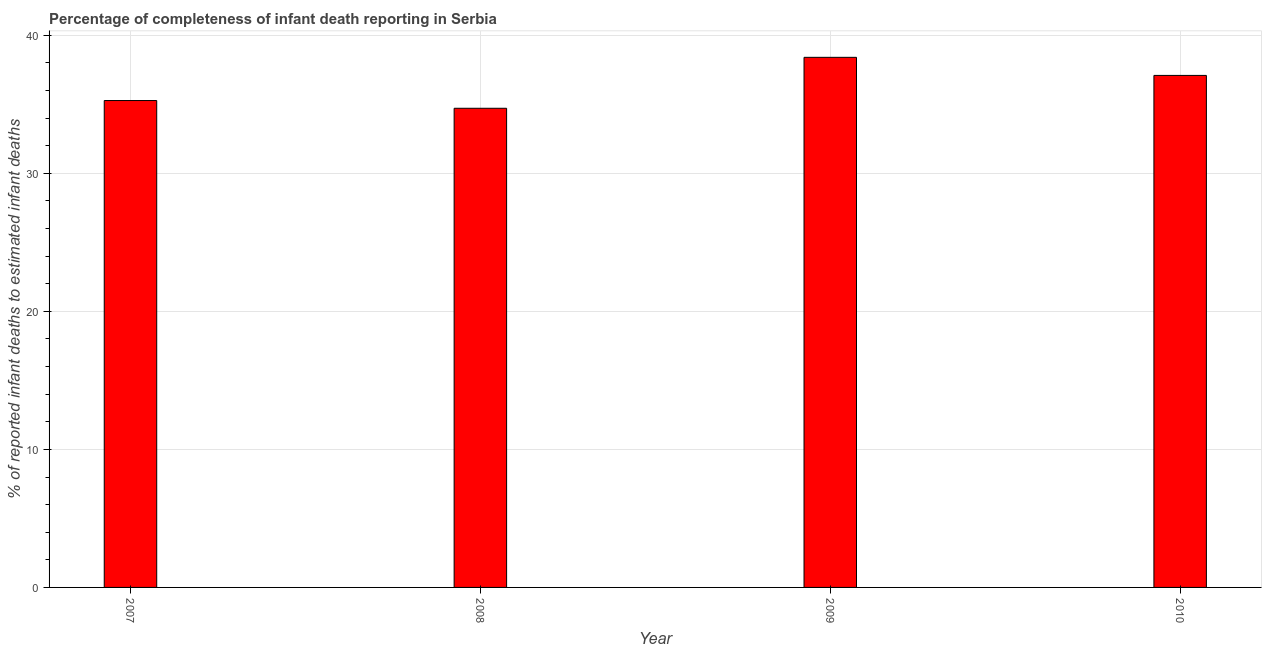Does the graph contain any zero values?
Keep it short and to the point. No. Does the graph contain grids?
Provide a short and direct response. Yes. What is the title of the graph?
Give a very brief answer. Percentage of completeness of infant death reporting in Serbia. What is the label or title of the X-axis?
Your response must be concise. Year. What is the label or title of the Y-axis?
Make the answer very short. % of reported infant deaths to estimated infant deaths. What is the completeness of infant death reporting in 2007?
Provide a succinct answer. 35.28. Across all years, what is the maximum completeness of infant death reporting?
Your answer should be very brief. 38.41. Across all years, what is the minimum completeness of infant death reporting?
Give a very brief answer. 34.72. In which year was the completeness of infant death reporting maximum?
Give a very brief answer. 2009. In which year was the completeness of infant death reporting minimum?
Your answer should be very brief. 2008. What is the sum of the completeness of infant death reporting?
Your answer should be very brief. 145.5. What is the difference between the completeness of infant death reporting in 2007 and 2009?
Provide a short and direct response. -3.13. What is the average completeness of infant death reporting per year?
Give a very brief answer. 36.38. What is the median completeness of infant death reporting?
Provide a succinct answer. 36.19. Do a majority of the years between 2008 and 2007 (inclusive) have completeness of infant death reporting greater than 2 %?
Provide a succinct answer. No. What is the ratio of the completeness of infant death reporting in 2007 to that in 2009?
Make the answer very short. 0.92. Is the completeness of infant death reporting in 2008 less than that in 2009?
Keep it short and to the point. Yes. Is the difference between the completeness of infant death reporting in 2009 and 2010 greater than the difference between any two years?
Ensure brevity in your answer.  No. What is the difference between the highest and the second highest completeness of infant death reporting?
Give a very brief answer. 1.31. Is the sum of the completeness of infant death reporting in 2007 and 2009 greater than the maximum completeness of infant death reporting across all years?
Your response must be concise. Yes. What is the difference between the highest and the lowest completeness of infant death reporting?
Make the answer very short. 3.69. In how many years, is the completeness of infant death reporting greater than the average completeness of infant death reporting taken over all years?
Your response must be concise. 2. How many bars are there?
Keep it short and to the point. 4. Are all the bars in the graph horizontal?
Ensure brevity in your answer.  No. What is the % of reported infant deaths to estimated infant deaths in 2007?
Your response must be concise. 35.28. What is the % of reported infant deaths to estimated infant deaths in 2008?
Provide a succinct answer. 34.72. What is the % of reported infant deaths to estimated infant deaths in 2009?
Ensure brevity in your answer.  38.41. What is the % of reported infant deaths to estimated infant deaths in 2010?
Offer a very short reply. 37.1. What is the difference between the % of reported infant deaths to estimated infant deaths in 2007 and 2008?
Provide a succinct answer. 0.56. What is the difference between the % of reported infant deaths to estimated infant deaths in 2007 and 2009?
Provide a short and direct response. -3.13. What is the difference between the % of reported infant deaths to estimated infant deaths in 2007 and 2010?
Keep it short and to the point. -1.82. What is the difference between the % of reported infant deaths to estimated infant deaths in 2008 and 2009?
Your answer should be compact. -3.69. What is the difference between the % of reported infant deaths to estimated infant deaths in 2008 and 2010?
Your response must be concise. -2.38. What is the difference between the % of reported infant deaths to estimated infant deaths in 2009 and 2010?
Provide a short and direct response. 1.31. What is the ratio of the % of reported infant deaths to estimated infant deaths in 2007 to that in 2008?
Ensure brevity in your answer.  1.02. What is the ratio of the % of reported infant deaths to estimated infant deaths in 2007 to that in 2009?
Your response must be concise. 0.92. What is the ratio of the % of reported infant deaths to estimated infant deaths in 2007 to that in 2010?
Offer a terse response. 0.95. What is the ratio of the % of reported infant deaths to estimated infant deaths in 2008 to that in 2009?
Ensure brevity in your answer.  0.9. What is the ratio of the % of reported infant deaths to estimated infant deaths in 2008 to that in 2010?
Your answer should be very brief. 0.94. What is the ratio of the % of reported infant deaths to estimated infant deaths in 2009 to that in 2010?
Give a very brief answer. 1.03. 